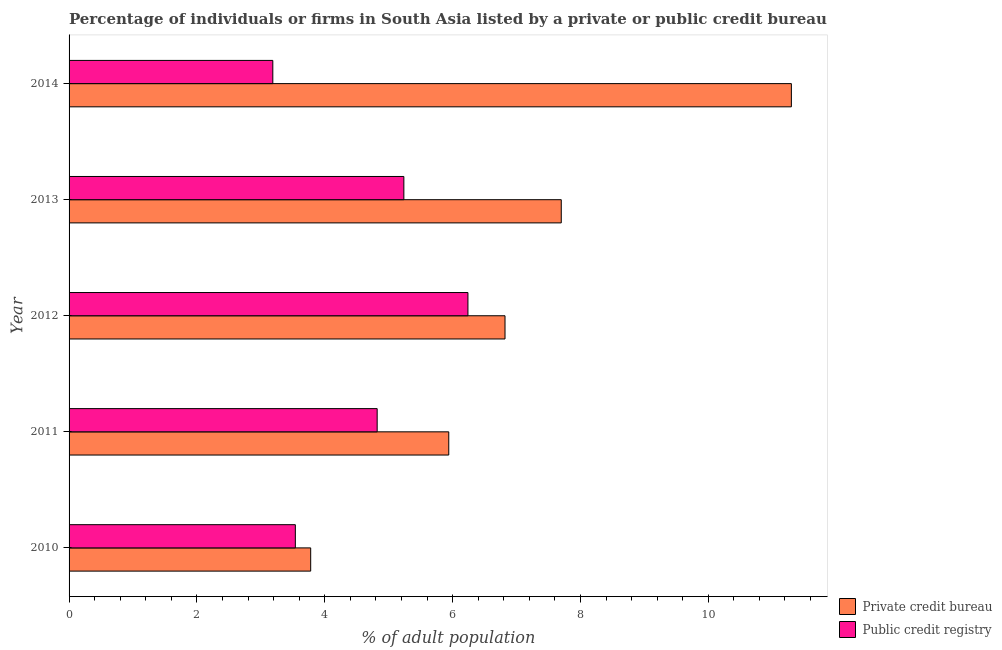How many groups of bars are there?
Give a very brief answer. 5. What is the percentage of firms listed by public credit bureau in 2010?
Provide a succinct answer. 3.54. Across all years, what is the minimum percentage of firms listed by public credit bureau?
Offer a terse response. 3.19. In which year was the percentage of firms listed by public credit bureau minimum?
Make the answer very short. 2014. What is the total percentage of firms listed by public credit bureau in the graph?
Offer a very short reply. 23.02. What is the difference between the percentage of firms listed by private credit bureau in 2010 and that in 2011?
Give a very brief answer. -2.16. What is the difference between the percentage of firms listed by public credit bureau in 2013 and the percentage of firms listed by private credit bureau in 2010?
Make the answer very short. 1.46. What is the average percentage of firms listed by public credit bureau per year?
Offer a very short reply. 4.61. In the year 2011, what is the difference between the percentage of firms listed by private credit bureau and percentage of firms listed by public credit bureau?
Ensure brevity in your answer.  1.12. What is the ratio of the percentage of firms listed by public credit bureau in 2011 to that in 2012?
Keep it short and to the point. 0.77. What is the difference between the highest and the second highest percentage of firms listed by public credit bureau?
Keep it short and to the point. 1. What is the difference between the highest and the lowest percentage of firms listed by private credit bureau?
Your answer should be compact. 7.52. What does the 1st bar from the top in 2014 represents?
Your answer should be very brief. Public credit registry. What does the 2nd bar from the bottom in 2014 represents?
Offer a terse response. Public credit registry. How many bars are there?
Provide a succinct answer. 10. Are all the bars in the graph horizontal?
Provide a short and direct response. Yes. Are the values on the major ticks of X-axis written in scientific E-notation?
Provide a succinct answer. No. Does the graph contain grids?
Keep it short and to the point. No. Where does the legend appear in the graph?
Offer a terse response. Bottom right. How are the legend labels stacked?
Make the answer very short. Vertical. What is the title of the graph?
Your answer should be very brief. Percentage of individuals or firms in South Asia listed by a private or public credit bureau. What is the label or title of the X-axis?
Ensure brevity in your answer.  % of adult population. What is the label or title of the Y-axis?
Make the answer very short. Year. What is the % of adult population of Private credit bureau in 2010?
Offer a very short reply. 3.78. What is the % of adult population in Public credit registry in 2010?
Offer a terse response. 3.54. What is the % of adult population of Private credit bureau in 2011?
Keep it short and to the point. 5.94. What is the % of adult population of Public credit registry in 2011?
Give a very brief answer. 4.82. What is the % of adult population of Private credit bureau in 2012?
Make the answer very short. 6.82. What is the % of adult population in Public credit registry in 2012?
Provide a succinct answer. 6.24. What is the % of adult population in Private credit bureau in 2013?
Make the answer very short. 7.7. What is the % of adult population in Public credit registry in 2013?
Provide a short and direct response. 5.24. What is the % of adult population of Private credit bureau in 2014?
Ensure brevity in your answer.  11.3. What is the % of adult population of Public credit registry in 2014?
Your answer should be very brief. 3.19. Across all years, what is the maximum % of adult population in Public credit registry?
Keep it short and to the point. 6.24. Across all years, what is the minimum % of adult population in Private credit bureau?
Your answer should be compact. 3.78. Across all years, what is the minimum % of adult population in Public credit registry?
Your answer should be very brief. 3.19. What is the total % of adult population of Private credit bureau in the graph?
Provide a succinct answer. 35.54. What is the total % of adult population of Public credit registry in the graph?
Give a very brief answer. 23.02. What is the difference between the % of adult population in Private credit bureau in 2010 and that in 2011?
Offer a terse response. -2.16. What is the difference between the % of adult population of Public credit registry in 2010 and that in 2011?
Offer a very short reply. -1.28. What is the difference between the % of adult population of Private credit bureau in 2010 and that in 2012?
Provide a succinct answer. -3.04. What is the difference between the % of adult population in Private credit bureau in 2010 and that in 2013?
Your response must be concise. -3.92. What is the difference between the % of adult population of Public credit registry in 2010 and that in 2013?
Offer a terse response. -1.7. What is the difference between the % of adult population of Private credit bureau in 2010 and that in 2014?
Ensure brevity in your answer.  -7.52. What is the difference between the % of adult population of Public credit registry in 2010 and that in 2014?
Provide a succinct answer. 0.35. What is the difference between the % of adult population in Private credit bureau in 2011 and that in 2012?
Your response must be concise. -0.88. What is the difference between the % of adult population in Public credit registry in 2011 and that in 2012?
Provide a short and direct response. -1.42. What is the difference between the % of adult population in Private credit bureau in 2011 and that in 2013?
Give a very brief answer. -1.76. What is the difference between the % of adult population in Public credit registry in 2011 and that in 2013?
Give a very brief answer. -0.42. What is the difference between the % of adult population of Private credit bureau in 2011 and that in 2014?
Offer a very short reply. -5.36. What is the difference between the % of adult population in Public credit registry in 2011 and that in 2014?
Make the answer very short. 1.63. What is the difference between the % of adult population in Private credit bureau in 2012 and that in 2013?
Ensure brevity in your answer.  -0.88. What is the difference between the % of adult population of Public credit registry in 2012 and that in 2013?
Provide a succinct answer. 1. What is the difference between the % of adult population in Private credit bureau in 2012 and that in 2014?
Offer a very short reply. -4.48. What is the difference between the % of adult population of Public credit registry in 2012 and that in 2014?
Make the answer very short. 3.05. What is the difference between the % of adult population in Private credit bureau in 2013 and that in 2014?
Offer a terse response. -3.6. What is the difference between the % of adult population of Public credit registry in 2013 and that in 2014?
Provide a short and direct response. 2.05. What is the difference between the % of adult population in Private credit bureau in 2010 and the % of adult population in Public credit registry in 2011?
Give a very brief answer. -1.04. What is the difference between the % of adult population of Private credit bureau in 2010 and the % of adult population of Public credit registry in 2012?
Provide a short and direct response. -2.46. What is the difference between the % of adult population of Private credit bureau in 2010 and the % of adult population of Public credit registry in 2013?
Keep it short and to the point. -1.46. What is the difference between the % of adult population of Private credit bureau in 2010 and the % of adult population of Public credit registry in 2014?
Your answer should be compact. 0.59. What is the difference between the % of adult population in Private credit bureau in 2011 and the % of adult population in Public credit registry in 2013?
Your answer should be very brief. 0.7. What is the difference between the % of adult population of Private credit bureau in 2011 and the % of adult population of Public credit registry in 2014?
Offer a terse response. 2.75. What is the difference between the % of adult population in Private credit bureau in 2012 and the % of adult population in Public credit registry in 2013?
Provide a succinct answer. 1.58. What is the difference between the % of adult population in Private credit bureau in 2012 and the % of adult population in Public credit registry in 2014?
Make the answer very short. 3.63. What is the difference between the % of adult population in Private credit bureau in 2013 and the % of adult population in Public credit registry in 2014?
Keep it short and to the point. 4.51. What is the average % of adult population of Private credit bureau per year?
Your response must be concise. 7.11. What is the average % of adult population of Public credit registry per year?
Provide a succinct answer. 4.61. In the year 2010, what is the difference between the % of adult population of Private credit bureau and % of adult population of Public credit registry?
Offer a terse response. 0.24. In the year 2011, what is the difference between the % of adult population of Private credit bureau and % of adult population of Public credit registry?
Provide a short and direct response. 1.12. In the year 2012, what is the difference between the % of adult population in Private credit bureau and % of adult population in Public credit registry?
Offer a terse response. 0.58. In the year 2013, what is the difference between the % of adult population of Private credit bureau and % of adult population of Public credit registry?
Your answer should be very brief. 2.46. In the year 2014, what is the difference between the % of adult population in Private credit bureau and % of adult population in Public credit registry?
Give a very brief answer. 8.11. What is the ratio of the % of adult population of Private credit bureau in 2010 to that in 2011?
Give a very brief answer. 0.64. What is the ratio of the % of adult population of Public credit registry in 2010 to that in 2011?
Your answer should be compact. 0.73. What is the ratio of the % of adult population in Private credit bureau in 2010 to that in 2012?
Make the answer very short. 0.55. What is the ratio of the % of adult population in Public credit registry in 2010 to that in 2012?
Ensure brevity in your answer.  0.57. What is the ratio of the % of adult population in Private credit bureau in 2010 to that in 2013?
Keep it short and to the point. 0.49. What is the ratio of the % of adult population in Public credit registry in 2010 to that in 2013?
Provide a succinct answer. 0.68. What is the ratio of the % of adult population in Private credit bureau in 2010 to that in 2014?
Offer a terse response. 0.33. What is the ratio of the % of adult population in Public credit registry in 2010 to that in 2014?
Make the answer very short. 1.11. What is the ratio of the % of adult population of Private credit bureau in 2011 to that in 2012?
Ensure brevity in your answer.  0.87. What is the ratio of the % of adult population of Public credit registry in 2011 to that in 2012?
Offer a very short reply. 0.77. What is the ratio of the % of adult population of Private credit bureau in 2011 to that in 2013?
Provide a short and direct response. 0.77. What is the ratio of the % of adult population of Public credit registry in 2011 to that in 2013?
Your answer should be compact. 0.92. What is the ratio of the % of adult population of Private credit bureau in 2011 to that in 2014?
Provide a short and direct response. 0.53. What is the ratio of the % of adult population in Public credit registry in 2011 to that in 2014?
Your answer should be very brief. 1.51. What is the ratio of the % of adult population in Private credit bureau in 2012 to that in 2013?
Make the answer very short. 0.89. What is the ratio of the % of adult population in Public credit registry in 2012 to that in 2013?
Your response must be concise. 1.19. What is the ratio of the % of adult population in Private credit bureau in 2012 to that in 2014?
Make the answer very short. 0.6. What is the ratio of the % of adult population of Public credit registry in 2012 to that in 2014?
Your response must be concise. 1.96. What is the ratio of the % of adult population in Private credit bureau in 2013 to that in 2014?
Your answer should be compact. 0.68. What is the ratio of the % of adult population of Public credit registry in 2013 to that in 2014?
Keep it short and to the point. 1.64. What is the difference between the highest and the lowest % of adult population of Private credit bureau?
Ensure brevity in your answer.  7.52. What is the difference between the highest and the lowest % of adult population of Public credit registry?
Make the answer very short. 3.05. 